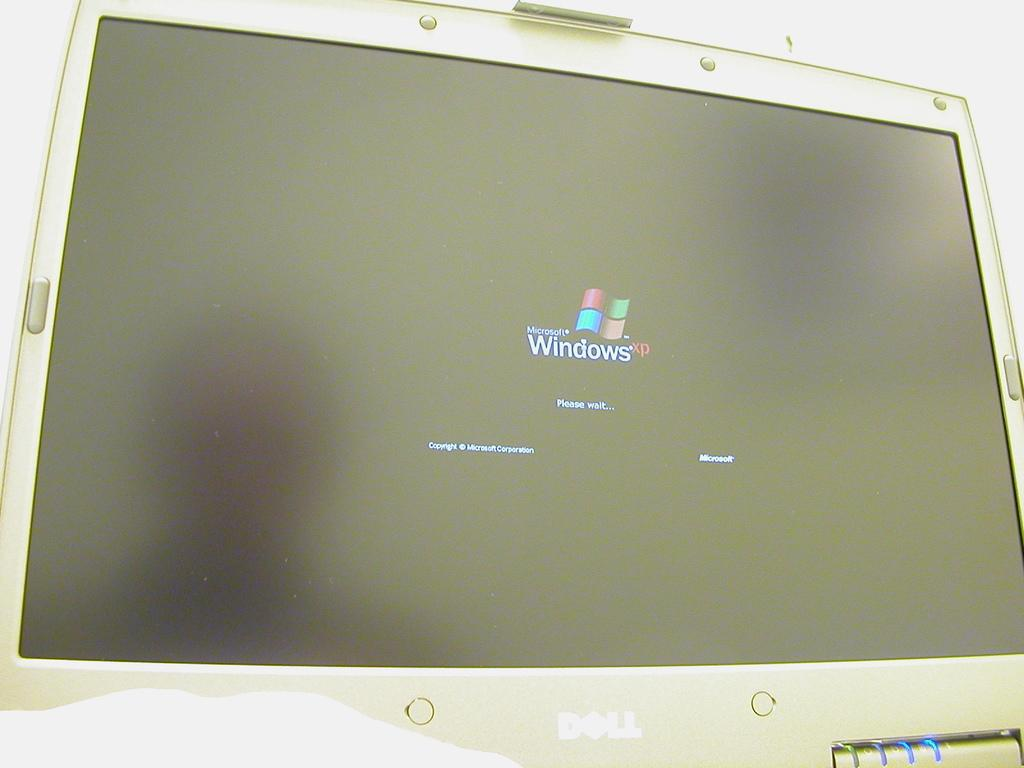<image>
Describe the image concisely. A Windows start screen on a white computer monitor. 